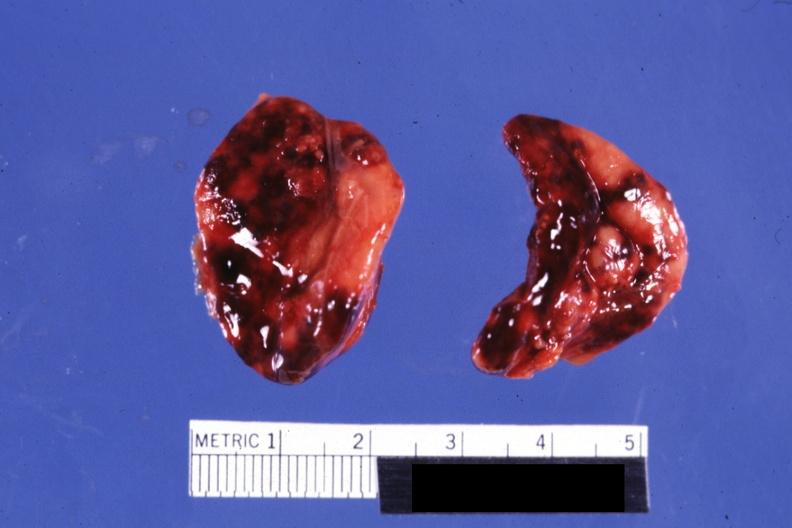what do not know history looks like placental abruption?
Answer the question using a single word or phrase. Focal hemorrhages 